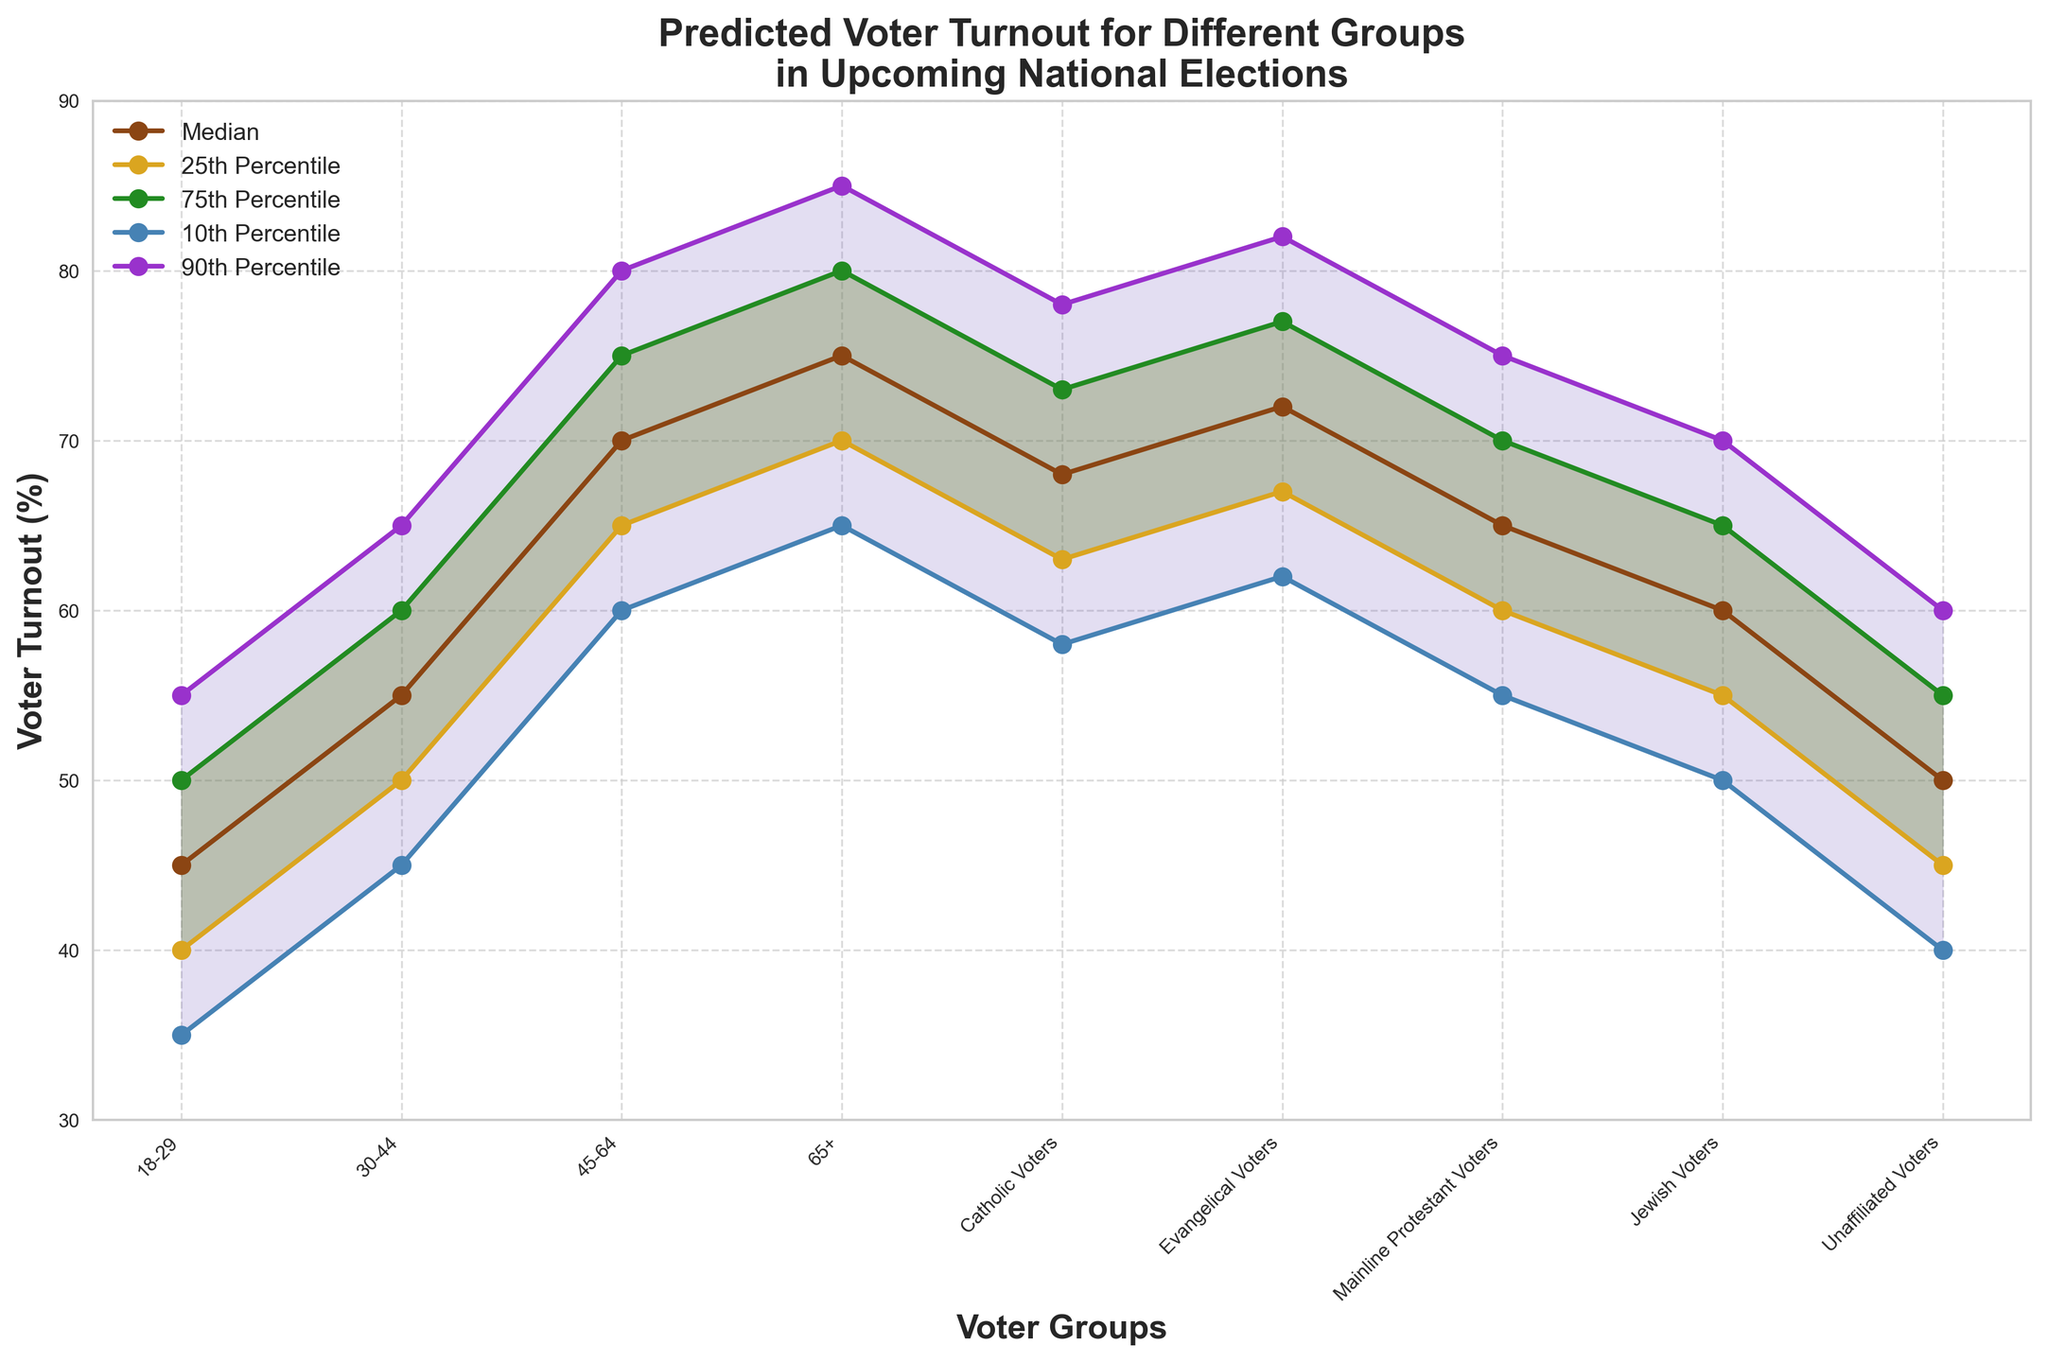What is the median expected voter turnout for the 18-29 age group? The median expected voter turnout for the 18-29 age group can be directly read from the plot.
Answer: 45 How does the median voter turnout for Mainline Protestant Voters compare to Evangelical Voters? Compare the median values for Mainline Protestant Voters (65) and Evangelical Voters (72).
Answer: Evangelical Voters have a higher median turnout Which age group has the highest predicted voter turnout at the 90th percentile? Look at the 90th percentile values for all age groups and identify the highest.
Answer: 65+ age group How many voter groups are shown in the figure? Count the number of distinct groups listed on the x-axis.
Answer: 9 What is the range of predicted voter turnout for Unaffiliated Voters between the 10th and 90th percentiles? Subtract the 10th percentile value for Unaffiliated Voters (40) from the 90th percentile value (60).
Answer: 20 Which religiously affiliated voter group has the smallest spread between the 25th and 75th percentiles? Compare the spread (75th percentile - 25th percentile) for all religiously affiliated voter groups.
Answer: Mainline Protestant Voters What is the median voter turnout for Catholic Voters, and how does it compare to the 65+ age group? Look at the median values for Catholic Voters (68) and the 65+ age group (75), then compare.
Answer: 65+ age group has a higher median turnout Is the predicted voter turnout for the 45-64 age group more spread out than for the 18-29 age group in the interquartile range? Compare the spreads between the 25th and 75th percentiles for both age groups (45-64: 75-65=10, 18-29: 50-40=10).
Answer: They have the same spread What is the title of the chart? Read the title directly from the chart.
Answer: Predicted Voter Turnout for Different Groups in Upcoming National Elections 